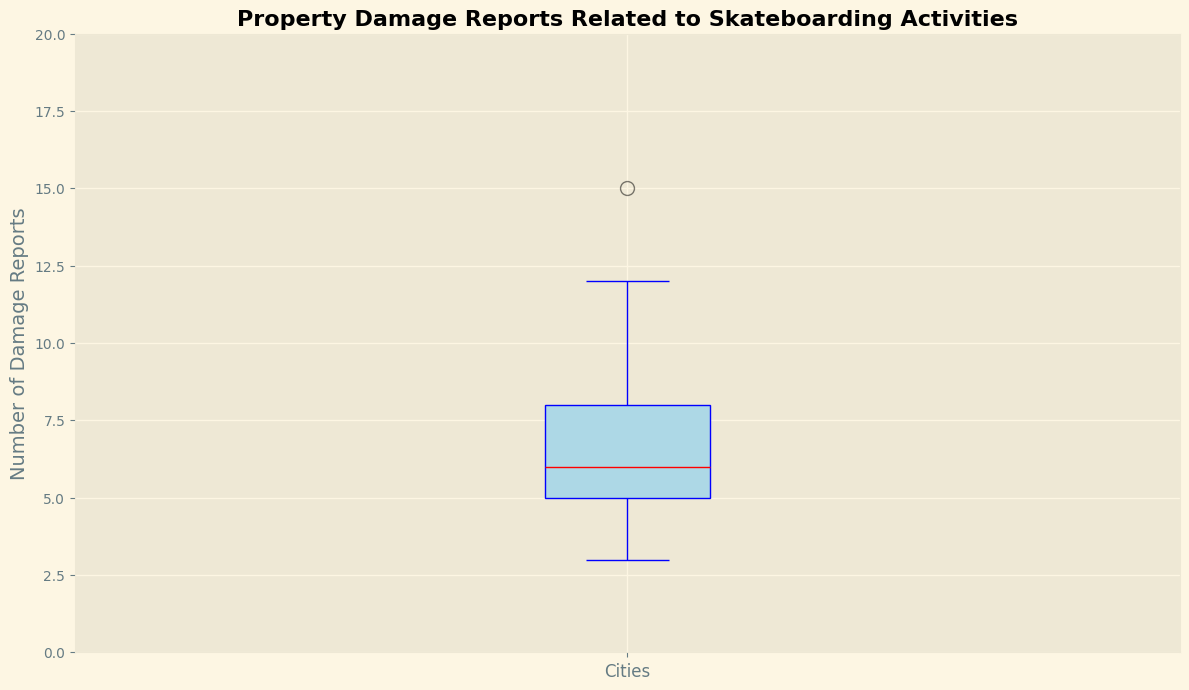What's the median number of property damage reports? The median value is indicated by the thick red line inside the box in the box plot. To determine the median, look at the value represented by this line.
Answer: 6.5 What's the interquartile range (IQR) of the property damage reports? The IQR is the difference between the third quartile (Q3) and the first quartile (Q1) values in the box plot. These can be found at the top and bottom edges of the box. Calculate the difference between Q3 and Q1.
Answer: 4 Which city appears to have the highest number of property damage reports? The highest value in the box plot is represented by the top whisker or outliers if present. Compare all values and identify the highest one.
Answer: Chicago How many cities have fewer than 5 property damage reports? Look at the number of data points below the value of 5 on the y-axis. These data points can either be within the whiskers or marked as individual outliers. Count them.
Answer: 6 What color represents the median line in the box plot? Identify the color of the line that is centrally placed in the box, spanning horizontally.
Answer: Red How is the spread of property damage reports visually represented in the plot? The spread is shown by the length of the box and the whiskers extending from it. The box shows the interquartile range and the whiskers indicate the overall range excluding outliers.
Answer: Box and Whiskers Between which values do the whiskers extend in the plot? Observe the lowest and highest points where the whiskers extend vertically from the box. This range represents the minimum and maximum values, excluding any outliers.
Answer: 3 to 15 How many cities have between 6 and 10 property damage reports, inclusive? Count the number of data points that are marked between the values of 6 and 10 on the y-axis. This includes both the values at the boundaries as well as those in between.
Answer: 13 Is there any city that had exactly 5 property damage reports? If so, how can you tell? Check if there are any data points marked exactly at the value 5 on the y-axis. This can be seen as individual values or part of the box plot indicating the distribution of data points.
Answer: Yes What is the lower quartile (Q1) value in the box plot? The lower quartile is the bottom edge of the box in the box plot. Identify the value represented at this point.
Answer: 4 